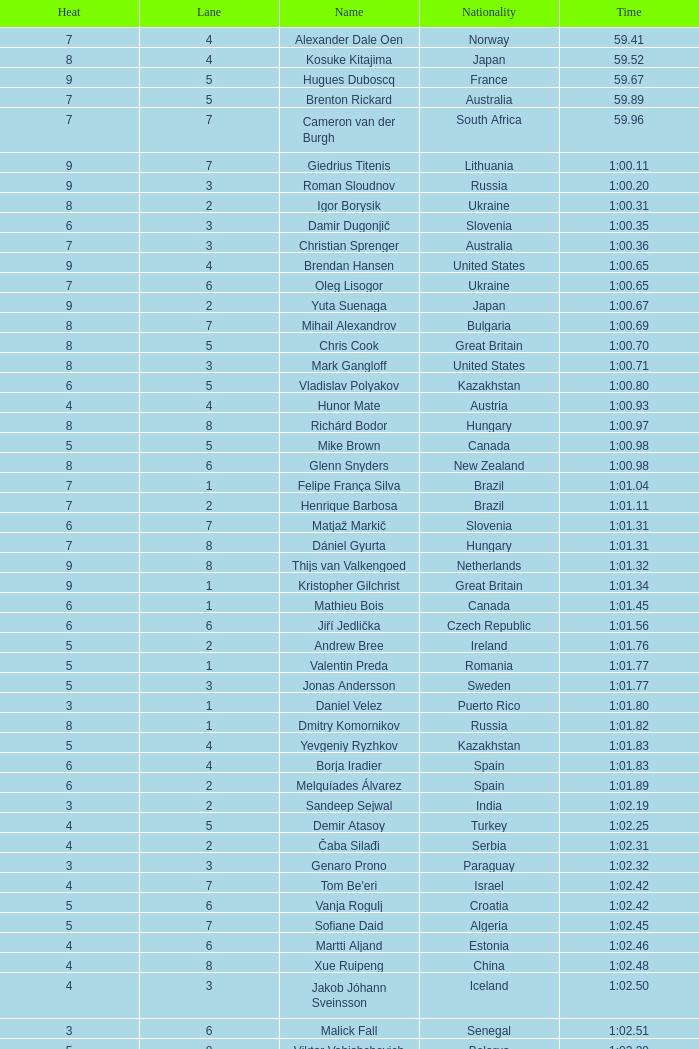What is the smallest lane number of Xue Ruipeng? 8.0. 